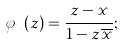Convert formula to latex. <formula><loc_0><loc_0><loc_500><loc_500>\varphi _ { x } ( z ) = \frac { z - x } { 1 - z \overline { x } } ;</formula> 